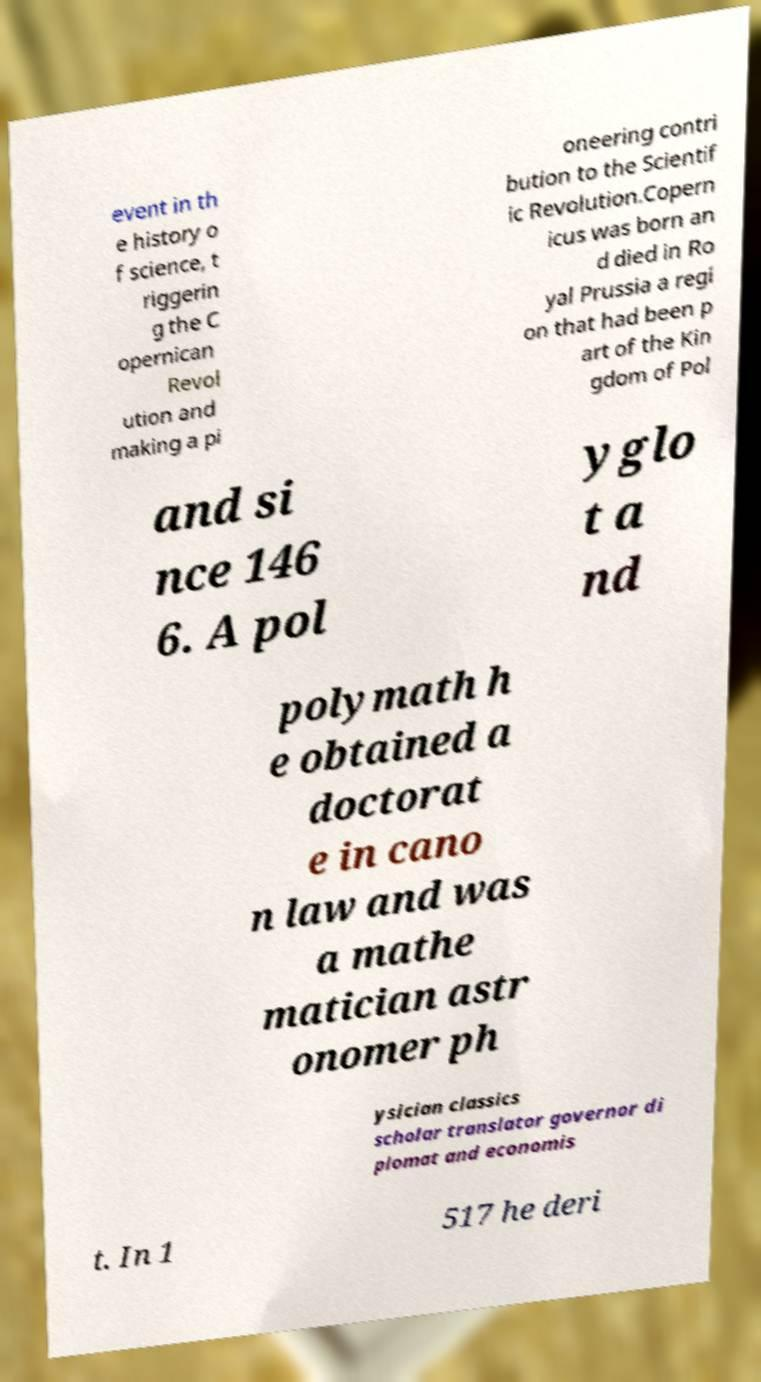Can you accurately transcribe the text from the provided image for me? event in th e history o f science, t riggerin g the C opernican Revol ution and making a pi oneering contri bution to the Scientif ic Revolution.Copern icus was born an d died in Ro yal Prussia a regi on that had been p art of the Kin gdom of Pol and si nce 146 6. A pol yglo t a nd polymath h e obtained a doctorat e in cano n law and was a mathe matician astr onomer ph ysician classics scholar translator governor di plomat and economis t. In 1 517 he deri 